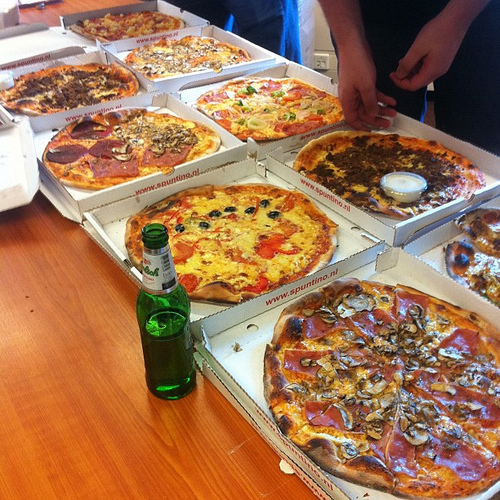Do you see boxes to the left of the vegetable in the top part of the photo? Yes, there are boxes to the left of the vegetable in the top part of the photo. 